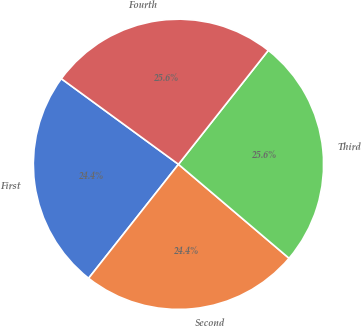Convert chart. <chart><loc_0><loc_0><loc_500><loc_500><pie_chart><fcel>First<fcel>Second<fcel>Third<fcel>Fourth<nl><fcel>24.42%<fcel>24.42%<fcel>25.58%<fcel>25.58%<nl></chart> 